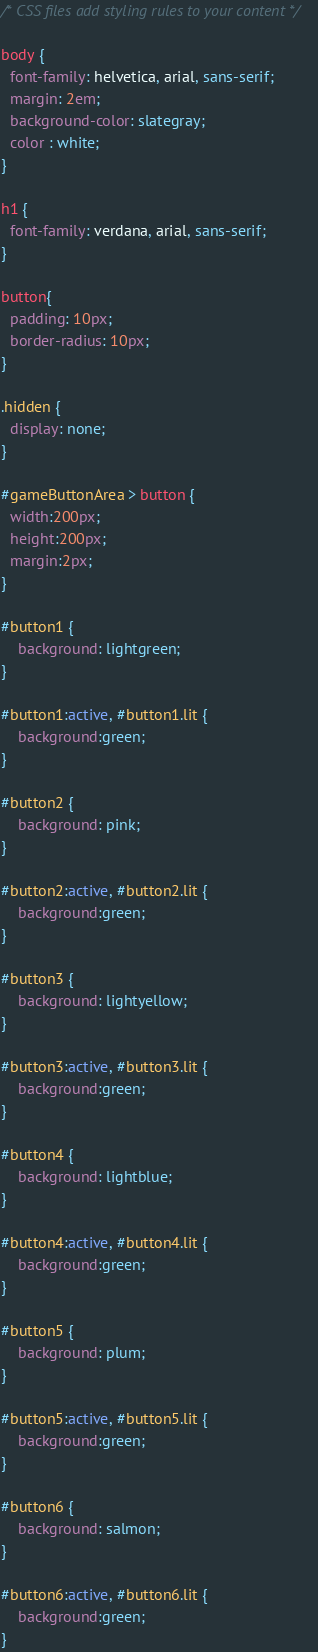Convert code to text. <code><loc_0><loc_0><loc_500><loc_500><_CSS_>/* CSS files add styling rules to your content */

body {
  font-family: helvetica, arial, sans-serif;
  margin: 2em;
  background-color: slategray;
  color : white;
}

h1 {
  font-family: verdana, arial, sans-serif;
}

button{
  padding: 10px;
  border-radius: 10px;
}

.hidden {
  display: none;
}

#gameButtonArea > button {
  width:200px;
  height:200px;
  margin:2px;
}

#button1 {
    background: lightgreen;
}

#button1:active, #button1.lit {
    background:green;
}

#button2 {
    background: pink;
}

#button2:active, #button2.lit {
    background:green;
}

#button3 {
    background: lightyellow;
}

#button3:active, #button3.lit {
    background:green;
}

#button4 {
    background: lightblue;
}

#button4:active, #button4.lit {
    background:green;
}

#button5 {
    background: plum;
}

#button5:active, #button5.lit {
    background:green;
}

#button6 {
    background: salmon;
}

#button6:active, #button6.lit {
    background:green;
}</code> 